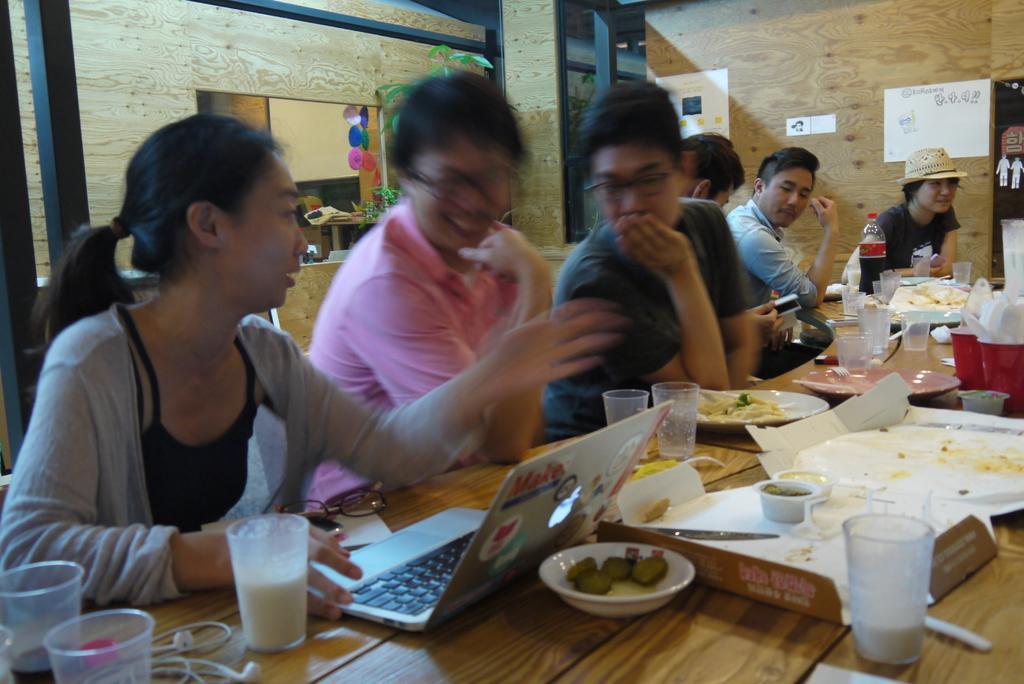In one or two sentences, can you explain what this image depicts? Here we can see a group of people are siting on the chair, and in front here is the table and laptop on it and some objects on it, and here is the wall. 